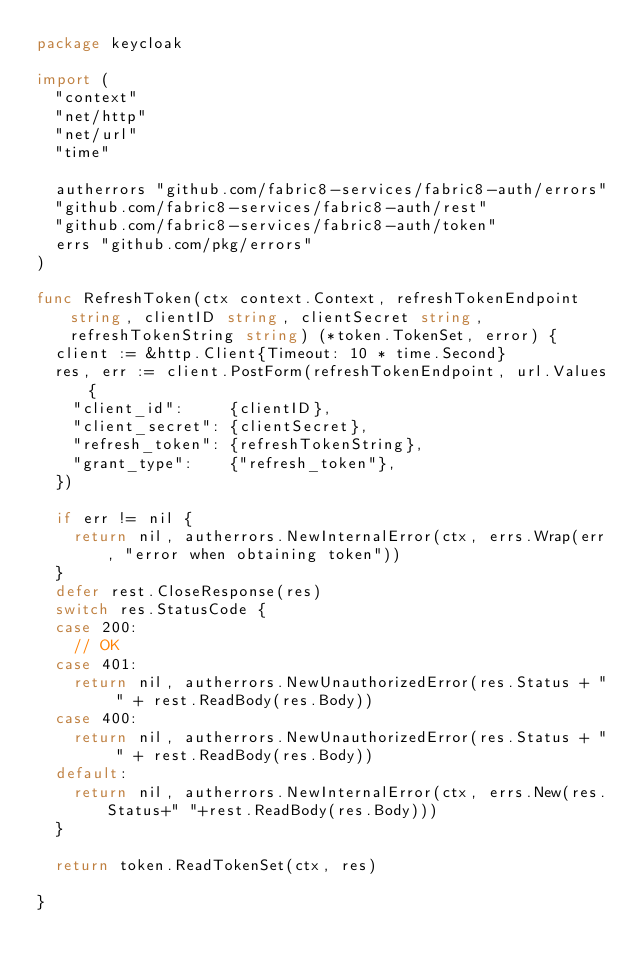<code> <loc_0><loc_0><loc_500><loc_500><_Go_>package keycloak

import (
	"context"
	"net/http"
	"net/url"
	"time"

	autherrors "github.com/fabric8-services/fabric8-auth/errors"
	"github.com/fabric8-services/fabric8-auth/rest"
	"github.com/fabric8-services/fabric8-auth/token"
	errs "github.com/pkg/errors"
)

func RefreshToken(ctx context.Context, refreshTokenEndpoint string, clientID string, clientSecret string, refreshTokenString string) (*token.TokenSet, error) {
	client := &http.Client{Timeout: 10 * time.Second}
	res, err := client.PostForm(refreshTokenEndpoint, url.Values{
		"client_id":     {clientID},
		"client_secret": {clientSecret},
		"refresh_token": {refreshTokenString},
		"grant_type":    {"refresh_token"},
	})

	if err != nil {
		return nil, autherrors.NewInternalError(ctx, errs.Wrap(err, "error when obtaining token"))
	}
	defer rest.CloseResponse(res)
	switch res.StatusCode {
	case 200:
		// OK
	case 401:
		return nil, autherrors.NewUnauthorizedError(res.Status + " " + rest.ReadBody(res.Body))
	case 400:
		return nil, autherrors.NewUnauthorizedError(res.Status + " " + rest.ReadBody(res.Body))
	default:
		return nil, autherrors.NewInternalError(ctx, errs.New(res.Status+" "+rest.ReadBody(res.Body)))
	}

	return token.ReadTokenSet(ctx, res)

}
</code> 